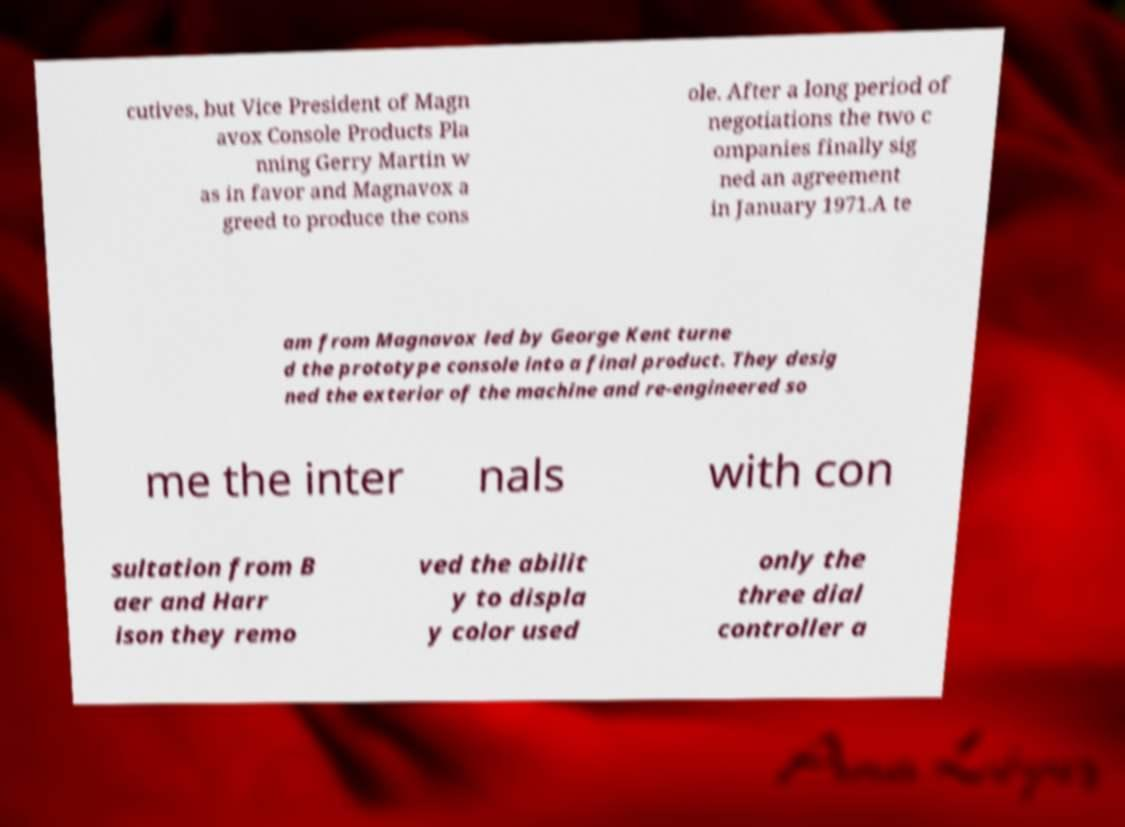Please read and relay the text visible in this image. What does it say? cutives, but Vice President of Magn avox Console Products Pla nning Gerry Martin w as in favor and Magnavox a greed to produce the cons ole. After a long period of negotiations the two c ompanies finally sig ned an agreement in January 1971.A te am from Magnavox led by George Kent turne d the prototype console into a final product. They desig ned the exterior of the machine and re-engineered so me the inter nals with con sultation from B aer and Harr ison they remo ved the abilit y to displa y color used only the three dial controller a 